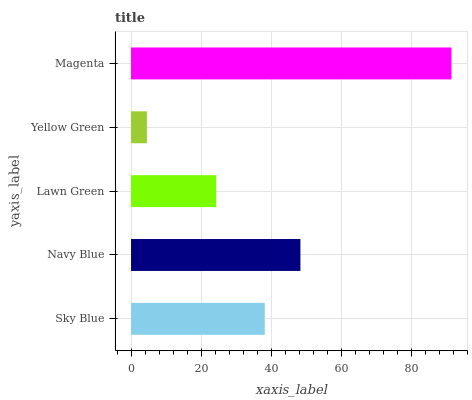Is Yellow Green the minimum?
Answer yes or no. Yes. Is Magenta the maximum?
Answer yes or no. Yes. Is Navy Blue the minimum?
Answer yes or no. No. Is Navy Blue the maximum?
Answer yes or no. No. Is Navy Blue greater than Sky Blue?
Answer yes or no. Yes. Is Sky Blue less than Navy Blue?
Answer yes or no. Yes. Is Sky Blue greater than Navy Blue?
Answer yes or no. No. Is Navy Blue less than Sky Blue?
Answer yes or no. No. Is Sky Blue the high median?
Answer yes or no. Yes. Is Sky Blue the low median?
Answer yes or no. Yes. Is Magenta the high median?
Answer yes or no. No. Is Lawn Green the low median?
Answer yes or no. No. 